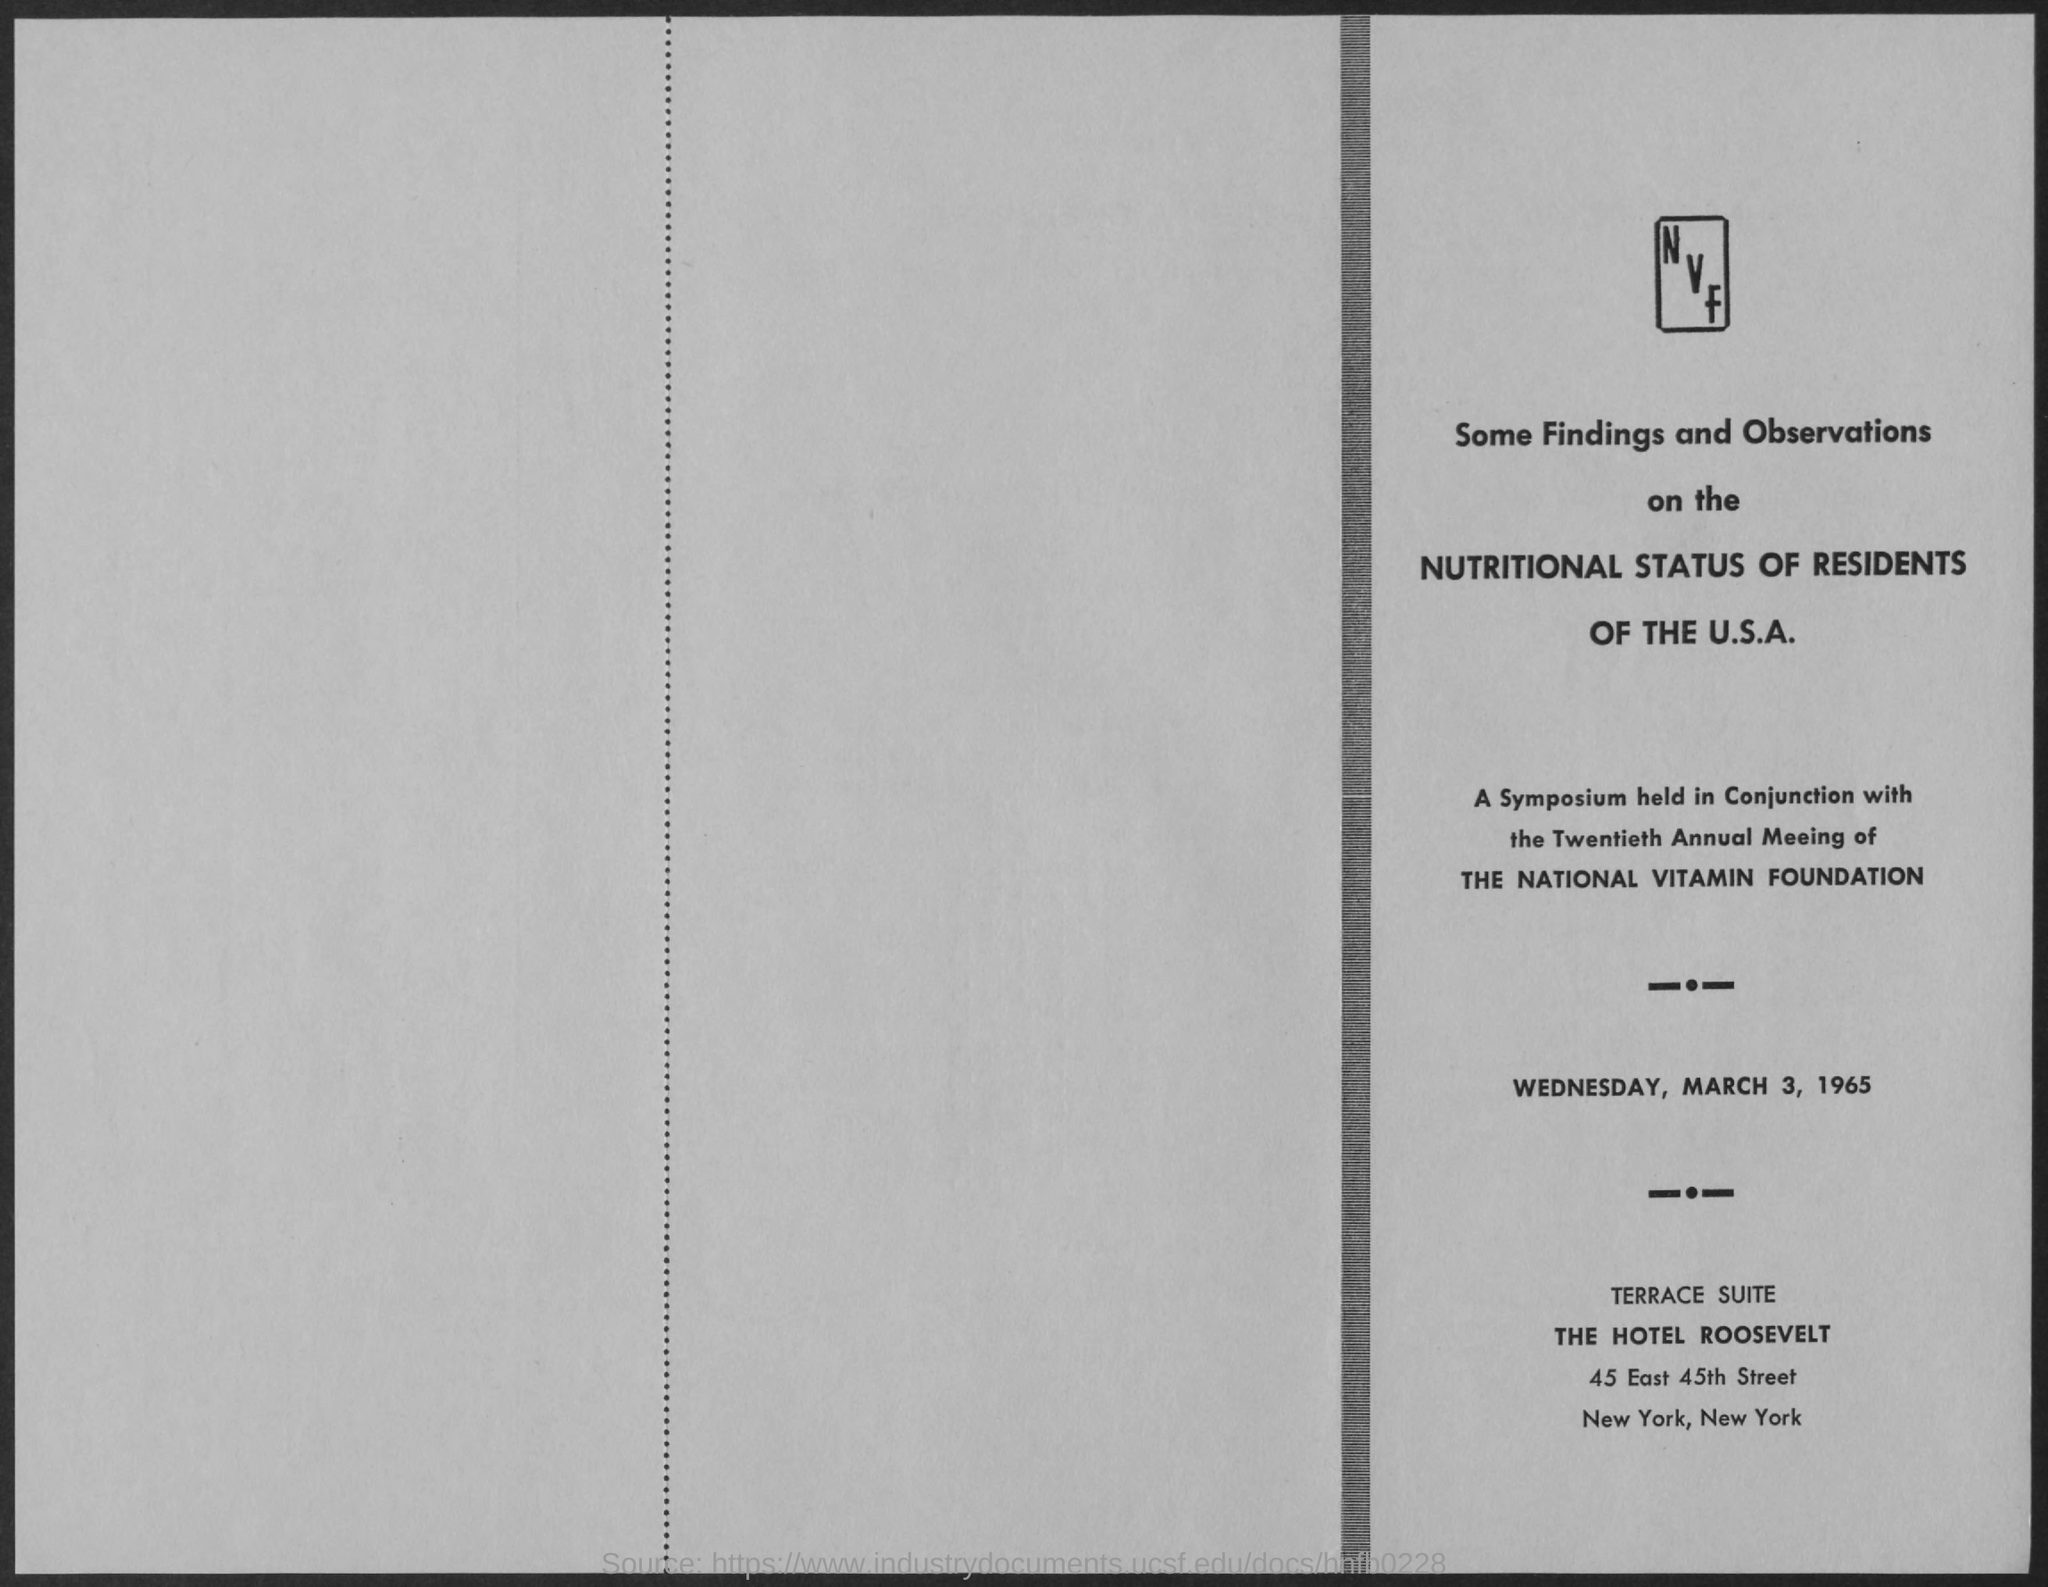What is the name of the foundation mentioned ?
Your answer should be very brief. The national vitamin foundation. What is the date mentioned in the given page ?
Your answer should be compact. Wednesday ,march 3, 1965. What is the suite mentioned ?
Keep it short and to the point. Terrace suite. What is the name of the hotel mentioned ?
Provide a short and direct response. THE HOTEL ROOSEVELT. 